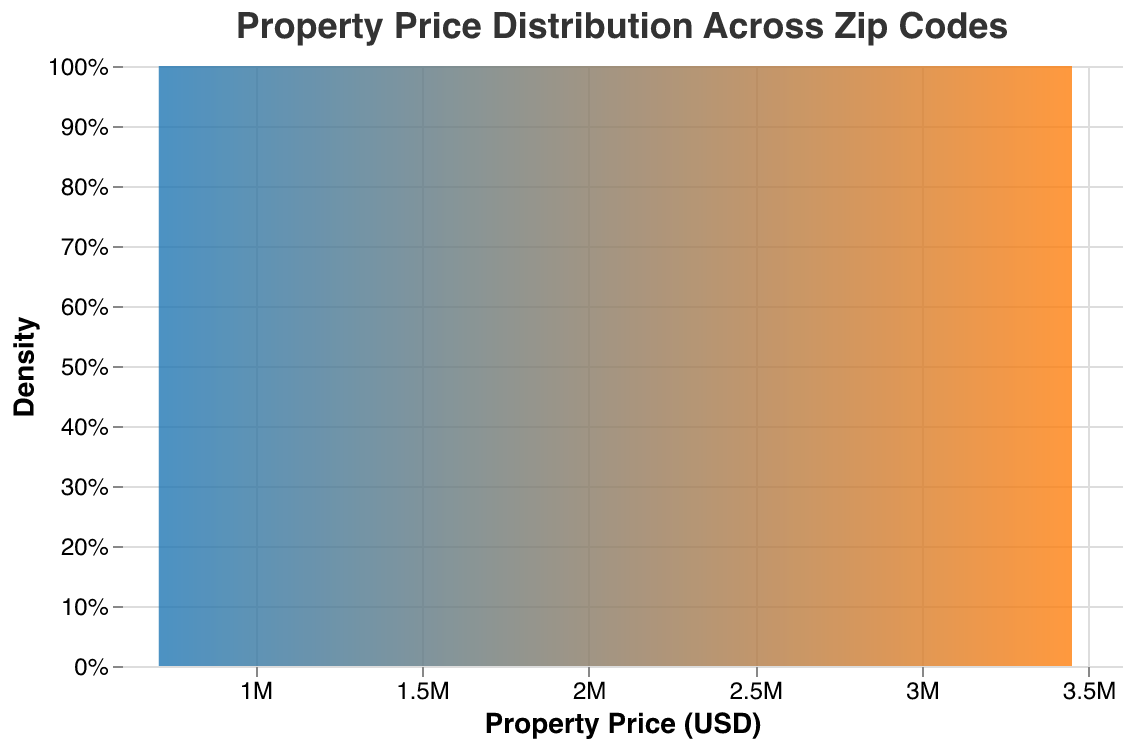What's the title of the plot? The title is prominently displayed at the top of the plot. It reads "Property Price Distribution Across Zip Codes".
Answer: Property Price Distribution Across Zip Codes Which axis represents Property Price? The x-axis represents Property Price, as indicated by the label "Property Price (USD)" on this axis.
Answer: x-axis What color gradient does the area mark use? The gradient used goes from a shade of blue on the left to a shade of orange on the right.
Answer: blue to orange Which zip code has the highest property prices indicated in the plot? Looking at the x-axis, the highest property prices are found at the far right of the density plot. Cross-referencing with the provided data, zip code 33109 has the highest price range, around 3,400,000 to 3,450,000.
Answer: 33109 How many property prices are in zip code 94105? From the provided data, we can count three data points corresponding to zip code 94105.
Answer: 3 What is the general shape of the distribution for properties in zip code 60614? The distribution for properties in 60614 appears concentrated around the prices 875,000 to 920,000. The shape should show a peak within this price range.
Answer: Concentrated around 875,000 to 920,000 Which zip code shows the widest range of property prices? From the density plot, compare the spreads of the different distributions. Zip code 33109 shows the widest range of property prices, spanning from 3,350,000 to roughly 3,450,000.
Answer: 33109 Compare the densities for the property prices of zip code 90210 and 10001. Which one has higher property prices? By observing the density plots for both zip codes, 90210 consistently appears further right on the x-axis compared to 10001, indicating higher property prices.
Answer: 90210 What is the color at the densest part of the distribution? The densest part of the distribution, where property prices are most concentrated, is represented by the most prominently visible part on the gradient, likely in a blend of blue and orange.
Answer: Blend of blue and orange What can you infer about the relative density of property prices between different zip codes? The density of property prices varies, with some zip codes having more tightly clustered property prices (higher peaks), while others are more spread out (wider ranges). This indicates varying degrees of price consistency within each zip code.
Answer: Varying density 